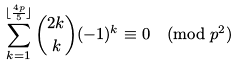<formula> <loc_0><loc_0><loc_500><loc_500>\sum _ { k = 1 } ^ { \lfloor \frac { 4 p } 5 \rfloor } \binom { 2 k } { k } ( - 1 ) ^ { k } \equiv 0 \pmod { p ^ { 2 } }</formula> 